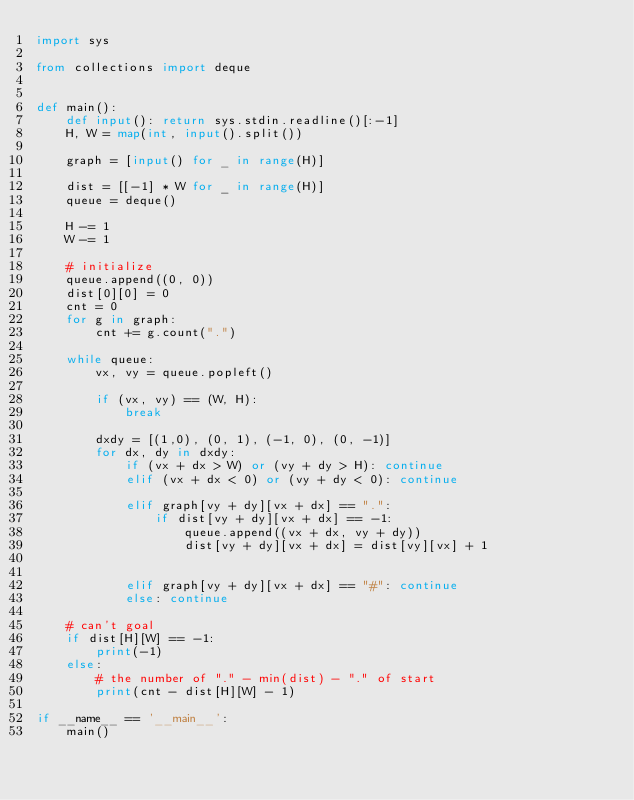<code> <loc_0><loc_0><loc_500><loc_500><_Python_>import sys

from collections import deque


def main():
    def input(): return sys.stdin.readline()[:-1]
    H, W = map(int, input().split())

    graph = [input() for _ in range(H)]

    dist = [[-1] * W for _ in range(H)]
    queue = deque()

    H -= 1
    W -= 1
    
    # initialize
    queue.append((0, 0))
    dist[0][0] = 0
    cnt = 0
    for g in graph:
        cnt += g.count(".")

    while queue:
        vx, vy = queue.popleft()

        if (vx, vy) == (W, H):
            break

        dxdy = [(1,0), (0, 1), (-1, 0), (0, -1)]
        for dx, dy in dxdy:
            if (vx + dx > W) or (vy + dy > H): continue
            elif (vx + dx < 0) or (vy + dy < 0): continue

            elif graph[vy + dy][vx + dx] == ".":
                if dist[vy + dy][vx + dx] == -1:
                    queue.append((vx + dx, vy + dy))
                    dist[vy + dy][vx + dx] = dist[vy][vx] + 1
                    

            elif graph[vy + dy][vx + dx] == "#": continue
            else: continue

    # can't goal
    if dist[H][W] == -1:
        print(-1)
    else:
        # the number of "." - min(dist) - "." of start
        print(cnt - dist[H][W] - 1)

if __name__ == '__main__':
    main()</code> 